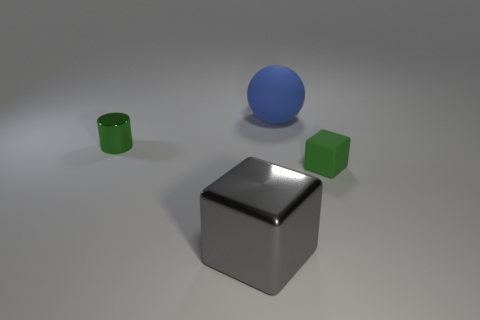Are there any other things that are the same shape as the tiny rubber object?
Offer a terse response. Yes. Does the blue ball have the same material as the big gray cube?
Give a very brief answer. No. There is a thing that is left of the large metal block; are there any big matte spheres on the left side of it?
Your response must be concise. No. What number of objects are in front of the large matte sphere and on the right side of the large cube?
Ensure brevity in your answer.  1. What shape is the shiny thing in front of the green cylinder?
Provide a succinct answer. Cube. What number of blue matte spheres are the same size as the gray block?
Your answer should be compact. 1. Is the color of the big thing in front of the small metallic cylinder the same as the cylinder?
Offer a very short reply. No. What is the material of the thing that is left of the blue rubber thing and behind the big metallic object?
Provide a short and direct response. Metal. Is the number of big green shiny objects greater than the number of tiny green shiny cylinders?
Keep it short and to the point. No. What color is the rubber object that is behind the small green object behind the object that is to the right of the matte ball?
Your answer should be compact. Blue. 